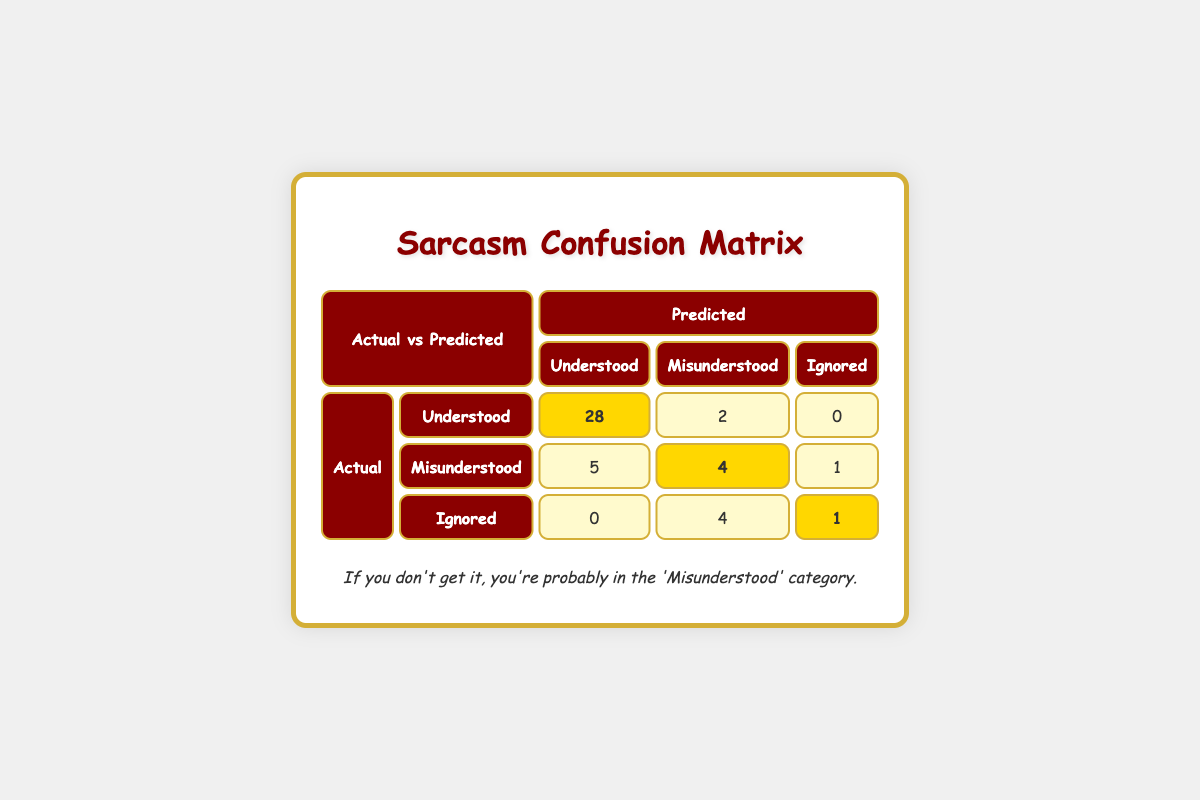What is the predicted count of responses that were misunderstood but actually understood? From the table, in the 'Predicted' row under 'Misunderstood', the value representing the count of responses that were predicted to be misunderstood but were actually understood is 5.
Answer: 5 What is the total number of responses that were ignored? To find this, we look at the 'Ignored' category under 'Actual'. The values in this row are 0 for predicted 'Understood', 4 for predicted 'Misunderstood', and 1 for predicted 'Ignored', adding them gives 0 + 4 + 1 = 5.
Answer: 5 Is it true that more responses were understood than misunderstood? By checking the 'understood' category in the actual column (30) and the misunderstood category (10), 30 is greater than 10, confirming it's true.
Answer: Yes How many responses were predicted to be understood when they were actually ignored? Looking under the 'Ignored' category for the 'Understood' prediction, we see that the value is 0. Hence, the predicted count of responses that were actually ignored is 0.
Answer: 0 What is the difference between the number of responses predicted to be understood and those predicted to be misunderstood? In the 'Predicted Understood' column, the value is 28, and for 'Predicted Misunderstood', the value is 2. The difference is 28 - 2 = 26.
Answer: 26 How many total responses were predicted correctly across all categories? Correct predictions can be summed from the main diagonal values: 'Understood' predicted as 'Understood' (28), 'Misunderstood' predicted as 'Misunderstood' (4), and 'Ignored' predicted as 'Ignored' (1), thus 28 + 4 + 1 = 33.
Answer: 33 Was there any case where responses were predicted to be ignored but were actually understood? Checking the 'Ignored' row, the value under 'Understood' is 0. Hence, there were no instances of this happening.
Answer: No What percentage of responses actually understood were predicted correctly? To find the percentage of correctly predicted understood responses, we take the predicted understood (28) divided by the actual understood (30), so (28/30) * 100 = 93.33%.
Answer: 93.33% What is the count of responses that were both predicted as misunderstood and actually misunderstood? Referring to the 'Misunderstood' predicted column under actual misunderstood, the value is 4, which indicates this count.
Answer: 4 